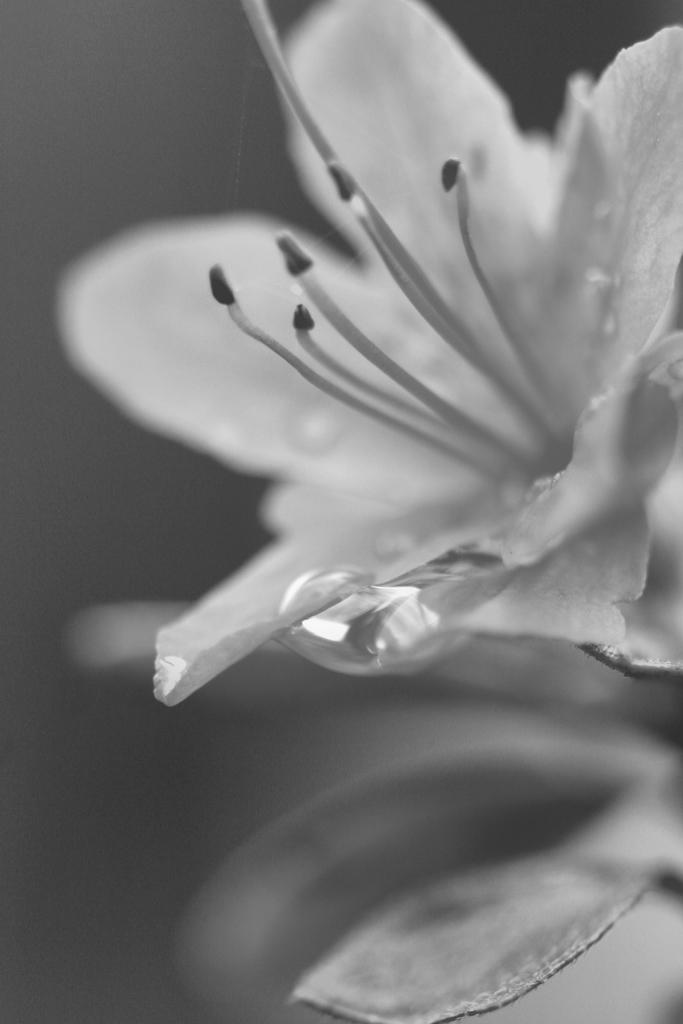What is the main subject of the image? There is a flower in the image. Can you describe any specific details about the flower? There is a water drop on the flower. How many pigs are visible in the image? There are no pigs present in the image; it features a flower with a water drop. What type of coat is the flower wearing in the image? The flower is not wearing a coat, as it is a plant and not a person or animal. 